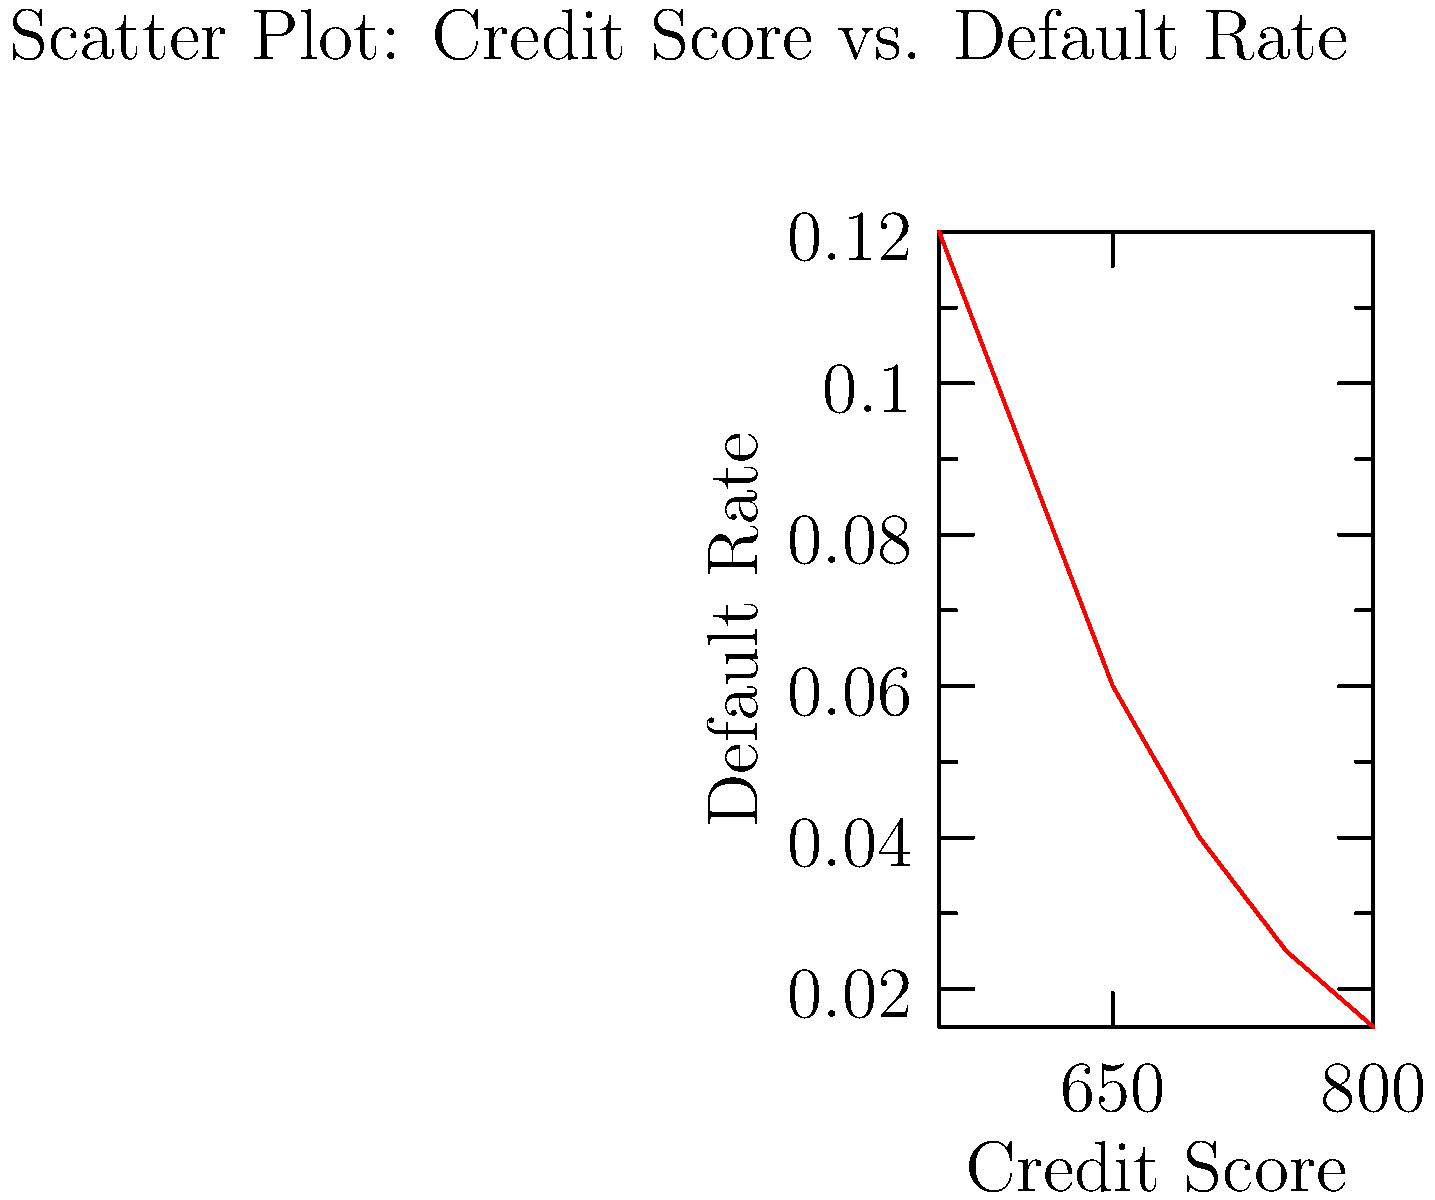Based on the scatter plot showing the relationship between credit scores and loan default rates, what conclusion can be drawn about the risk associated with approving loans for customers with lower credit scores? To answer this question, we need to analyze the trend in the scatter plot:

1. Observe the x-axis (Credit Score) and y-axis (Default Rate).
2. Notice that as the credit score increases (moving right on the x-axis), the default rate decreases (moving down on the y-axis).
3. This indicates an inverse relationship between credit scores and default rates.
4. At lower credit scores (left side of the plot), the default rates are higher.
5. At higher credit scores (right side of the plot), the default rates are lower.
6. The relationship appears to be non-linear, with a steeper decline in default rates at lower credit scores.

Given this analysis, we can conclude that approving loans for customers with lower credit scores poses a higher risk to the bank. These customers are more likely to default on their loans, potentially leading to financial losses for the institution.
Answer: Higher risk of loan default for lower credit scores 